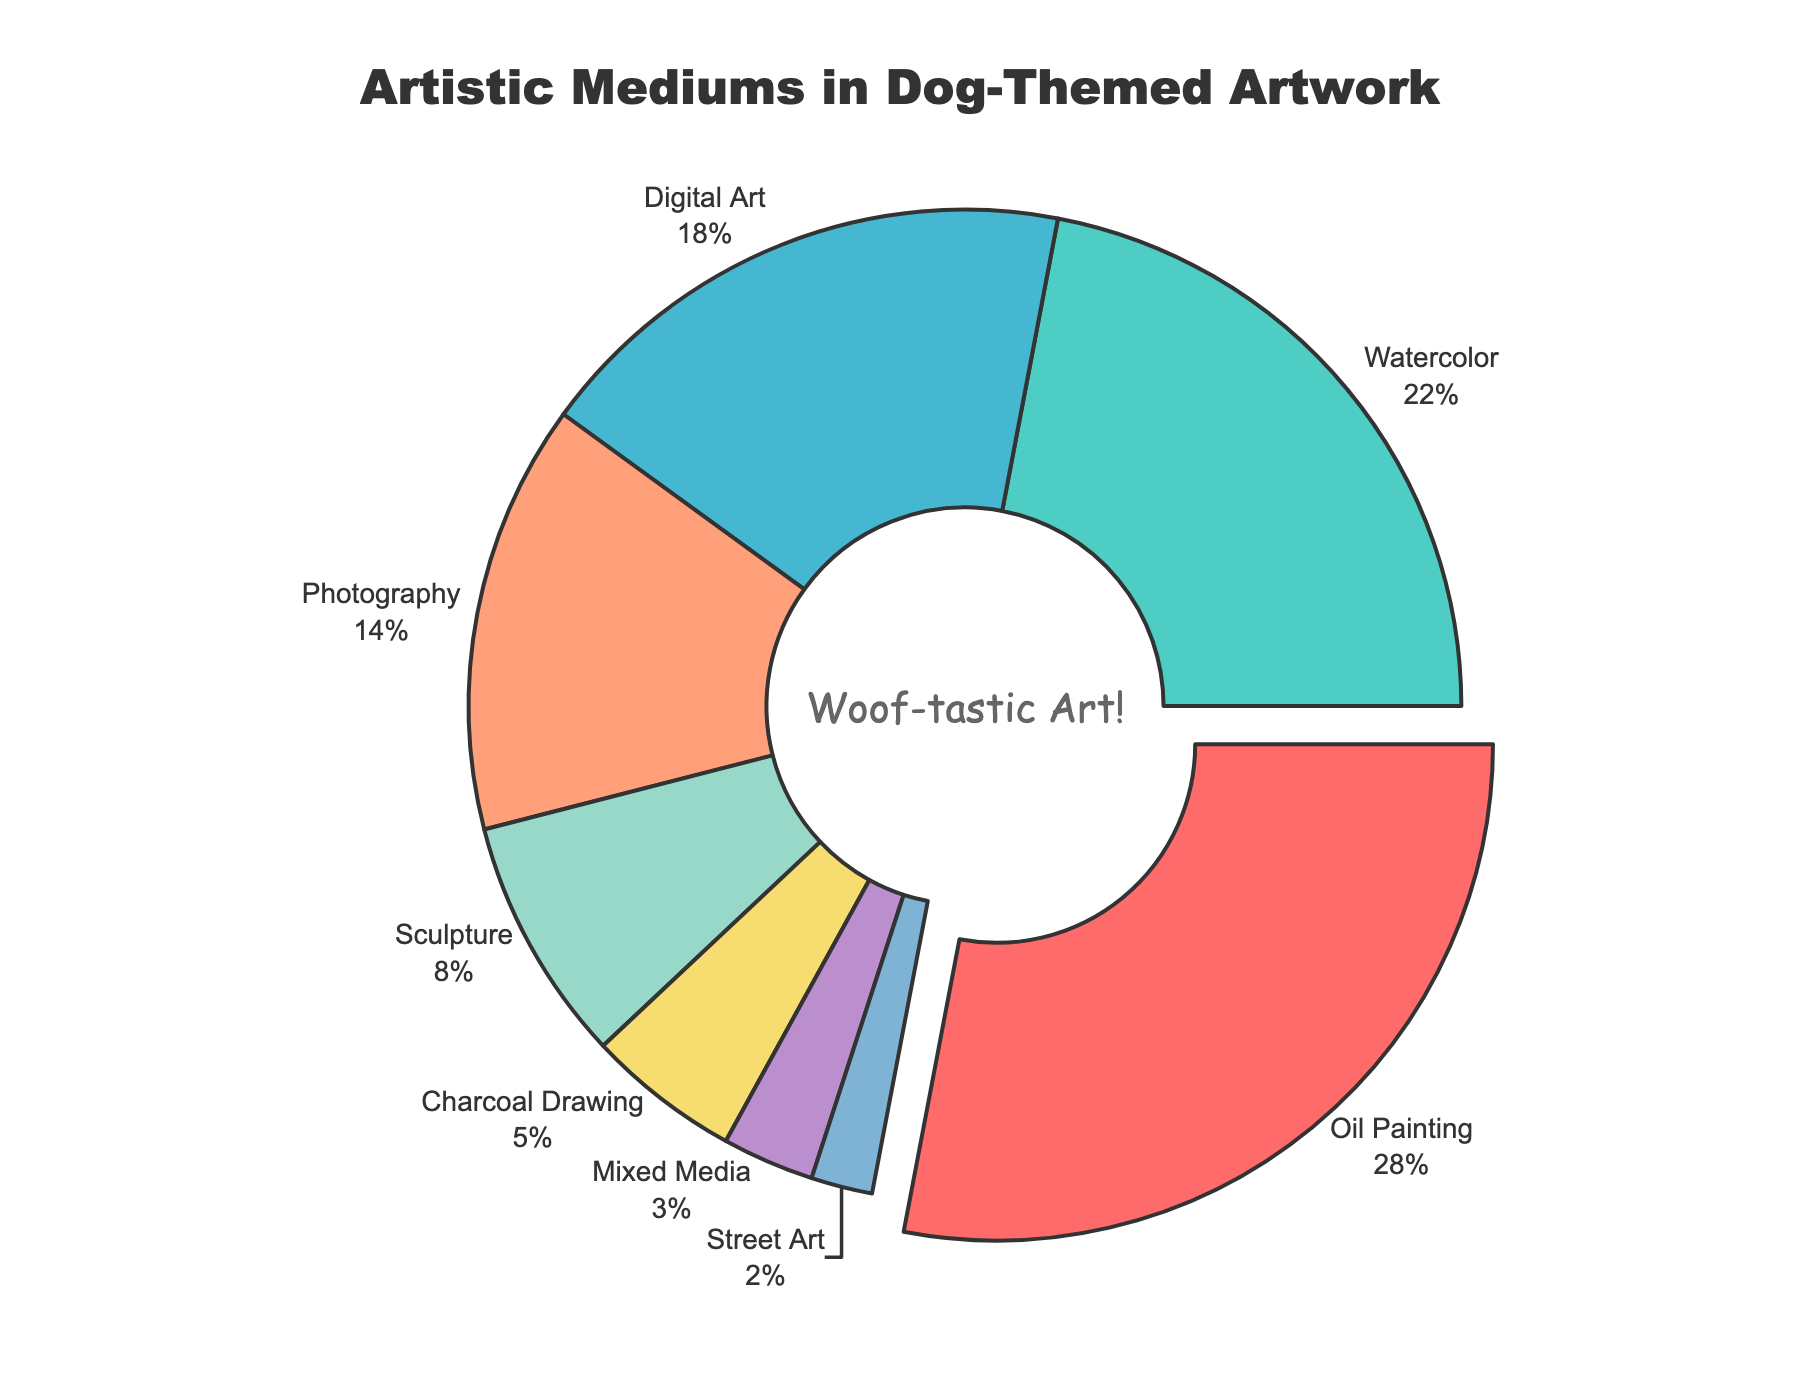What is the most commonly used medium in dog-themed artwork? The most commonly used medium can be identified as the one with the largest percentage. From the data, Oil Painting has the highest percentage at 28%.
Answer: Oil Painting Which medium has the least representation in dog-themed artwork? The least represented medium is the one with the smallest percentage. From the data, Street Art has the smallest percentage at 2%.
Answer: Street Art How much more popular is Oil Painting compared to Digital Art? To find how much more popular Oil Painting is compared to Digital Art, subtract the percentage of Digital Art from the percentage of Oil Painting. Therefore, 28% - 18% = 10%.
Answer: 10% What is the combined percentage of Watercolor and Charcoal Drawing? To find the combined percentage, add the percentages of Watercolor and Charcoal Drawing. So, 22% + 5% = 27%.
Answer: 27% If the mediums were categorized as traditional (Oil Painting, Watercolor, Sculpture, Charcoal Drawing) and modern (Digital Art, Photography, Mixed Media, Street Art), what percentage of the artwork is traditional? Add the percentages of traditional mediums and compare it to the overall sum. Traditional mediums are Oil Painting (28%), Watercolor (22%), Sculpture (8%), and Charcoal Drawing (5%). Therefore, 28% + 22% + 8% + 5% = 63%.
Answer: 63% Which medium is more popular: Photography or Sculpture? By comparing the percentages of Photography and Sculpture, Photography has 14%, and Sculpture has 8%. Photography is more popular.
Answer: Photography What percentage difference is there between the Mediums with the second and third highest percentages? The second highest percentage is Watercolor (22%) and the third highest is Digital Art (18%). The difference is calculated as 22% - 18% = 4%.
Answer: 4% What is the total percentage of the less popular mediums (Mixed Media and Street Art)? Add the percentages of Mixed Media and Street Art. So, 3% + 2% = 5%.
Answer: 5% Which mediums have a percentage greater than 20%? Mediums with percentages greater than 20% are Oil Painting (28%) and Watercolor (22%).
Answer: Oil Painting and Watercolor What is the average percentage of all mediums? To find the average percentage, sum all the percentages and divide by the number of mediums. Total sum is 28% + 22% + 18% + 14% + 8% + 5% + 3% + 2% = 100%. There are 8 mediums, so the average is 100% / 8 = 12.5%.
Answer: 12.5% 